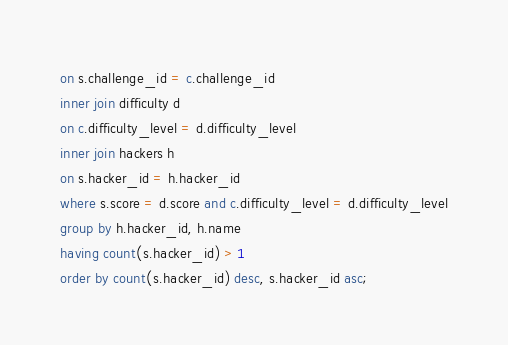<code> <loc_0><loc_0><loc_500><loc_500><_SQL_>on s.challenge_id = c.challenge_id
inner join difficulty d
on c.difficulty_level = d.difficulty_level 
inner join hackers h
on s.hacker_id = h.hacker_id
where s.score = d.score and c.difficulty_level = d.difficulty_level
group by h.hacker_id, h.name
having count(s.hacker_id) > 1
order by count(s.hacker_id) desc, s.hacker_id asc;</code> 